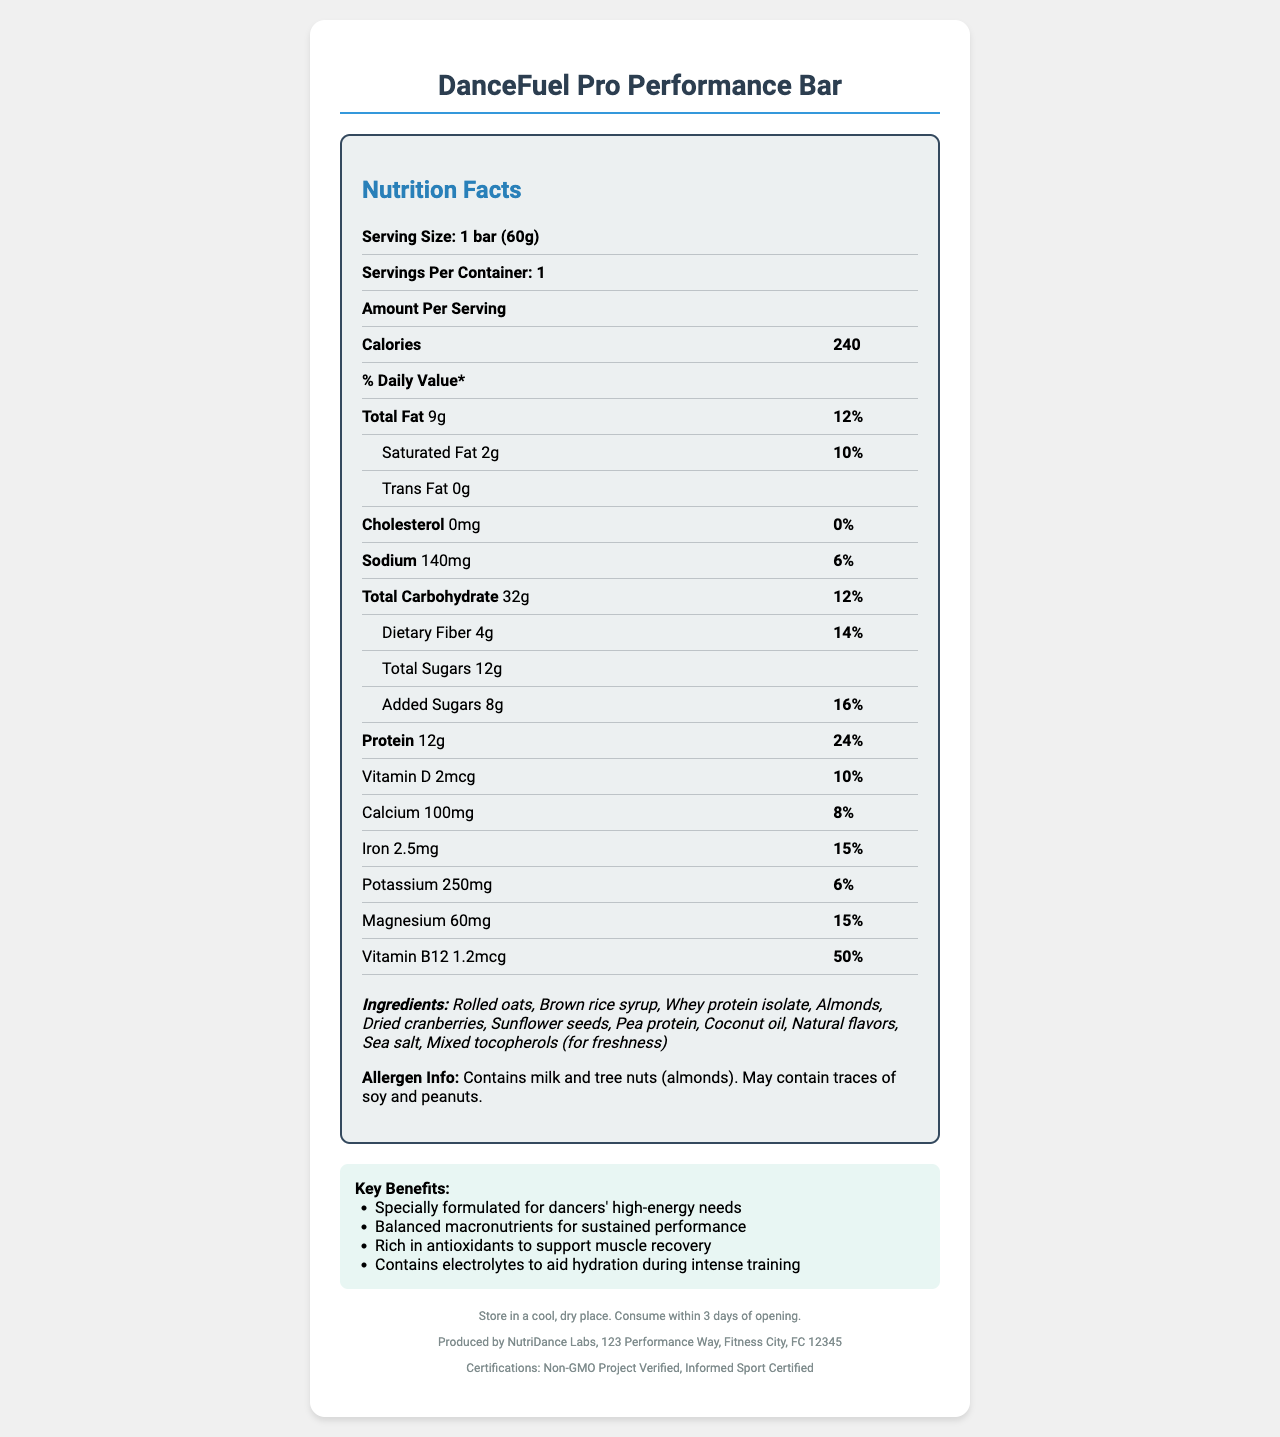which product is being analyzed in the document? The product name is clearly stated at the top of the document.
Answer: DanceFuel Pro Performance Bar what is the serving size of the DanceFuel Pro Performance Bar? The serving size is listed near the top of the Nutrition Facts section.
Answer: 1 bar (60g) how many calories are in one serving of the DanceFuel Pro Performance Bar? The calorie content per serving is mentioned under the "Amount Per Serving" section.
Answer: 240 calories what percentage of the daily value of iron does one serving provide? The daily value percentage for iron is listed in the Nutrition Facts table.
Answer: 15% which ingredient provides protein in the DanceFuel Pro Performance Bar? Both ingredients are listed in the ingredients section and are known protein sources.
Answer: Whey protein isolate, Pea protein how much dietary fiber does the bar contain? The dietary fiber content is specified in the Nutrition Facts table under "Total Carbohydrate."
Answer: 4g is there any trans fat in the DanceFuel Pro Performance Bar? The Nutrition Facts label shows "Trans Fat 0g."
Answer: No is this product suitable for someone with a peanut allergy? The allergen information states that the product contains milk and tree nuts (almonds) and may contain traces of soy and peanuts.
Answer: No what is the primary purpose of the DanceFuel Pro Performance Bar? This is stated in the claim statements under "Key Benefits."
Answer: Specially formulated for dancers' high-energy needs how long should the product be consumed after opening it? The storage instructions indicate that the product should be consumed within 3 days of opening.
Answer: Within 3 days which of the following is true about the amount of calcium in one serving?
1. Provides 10% of the daily value
2. Provides 15% of the daily value
3. Provides 8% of the daily value The Nutrition Facts table shows that the bar provides 8% of the daily value of calcium.
Answer: 3 which of these certifications does the DanceFuel Pro Performance Bar have?
a. USDA Certified Organic
b. Non-GMO Project Verified
c. Gluten-Free Certified The certifications listed at the bottom of the document include "Non-GMO Project Verified" and "Informed Sport Certified."
Answer: b does the bar contain any added sugars? The Nutrition Facts label lists "Added Sugars 8g."
Answer: Yes describe the main points covered by the document about the DanceFuel Pro Performance Bar. The Nutrition Facts section provides a breakdown of macronutrients and micronutrients, while the ingredients and allergen information offer insights into the product's composition. The claim statements and certification details further emphasize the product's benefits and quality assurance.
Answer: The document provides detailed nutrition information, ingredients, allergen information, claim statements, storage instructions, manufacturer details, and certifications for the DanceFuel Pro Performance Bar. Key highlights include its suitability for dancers, balanced macronutrients, antioxidant content, and beneficial vitamins and minerals. what is the source of the data? The source of the data, such as the method of analysis, is not mentioned in the document. Only the manufacturer is listed.
Answer: Cannot be determined 